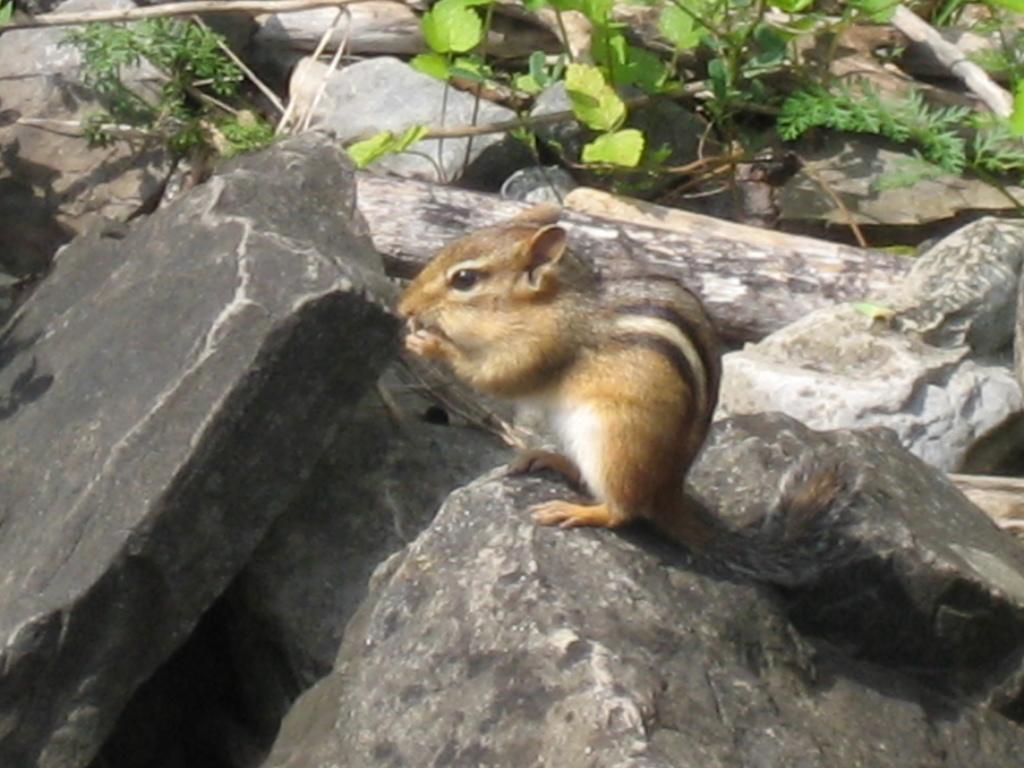How would you summarize this image in a sentence or two? Here I can see few rocks and wooden trunks. In the middle of the image there is a squirrel on a rock. At the top of the image few leaves are visible. 